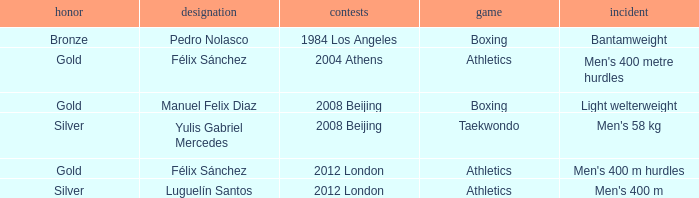Which Name had a Games of 2008 beijing, and a Medal of gold? Manuel Felix Diaz. Would you be able to parse every entry in this table? {'header': ['honor', 'designation', 'contests', 'game', 'incident'], 'rows': [['Bronze', 'Pedro Nolasco', '1984 Los Angeles', 'Boxing', 'Bantamweight'], ['Gold', 'Félix Sánchez', '2004 Athens', 'Athletics', "Men's 400 metre hurdles"], ['Gold', 'Manuel Felix Diaz', '2008 Beijing', 'Boxing', 'Light welterweight'], ['Silver', 'Yulis Gabriel Mercedes', '2008 Beijing', 'Taekwondo', "Men's 58 kg"], ['Gold', 'Félix Sánchez', '2012 London', 'Athletics', "Men's 400 m hurdles"], ['Silver', 'Luguelín Santos', '2012 London', 'Athletics', "Men's 400 m"]]} 